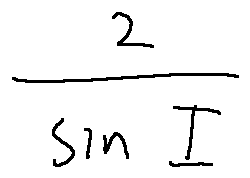<formula> <loc_0><loc_0><loc_500><loc_500>\frac { 2 } { \sin I }</formula> 